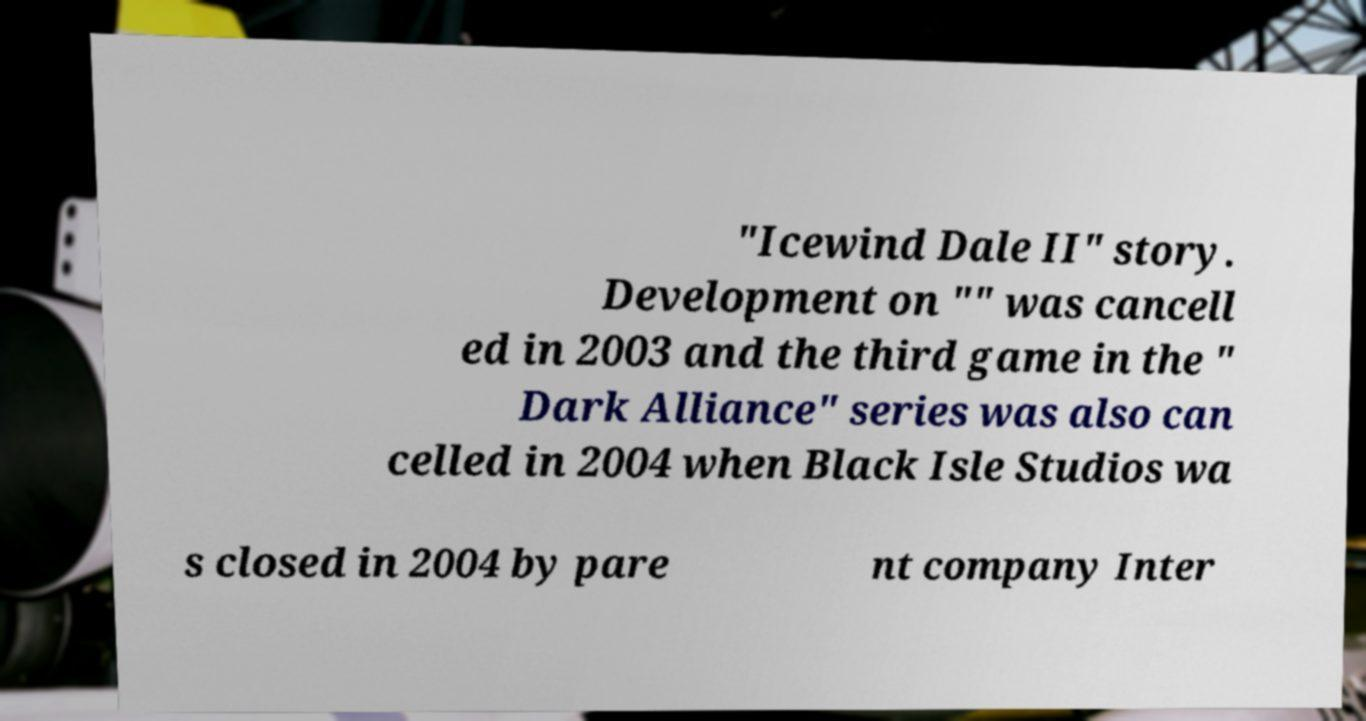There's text embedded in this image that I need extracted. Can you transcribe it verbatim? "Icewind Dale II" story. Development on "" was cancell ed in 2003 and the third game in the " Dark Alliance" series was also can celled in 2004 when Black Isle Studios wa s closed in 2004 by pare nt company Inter 